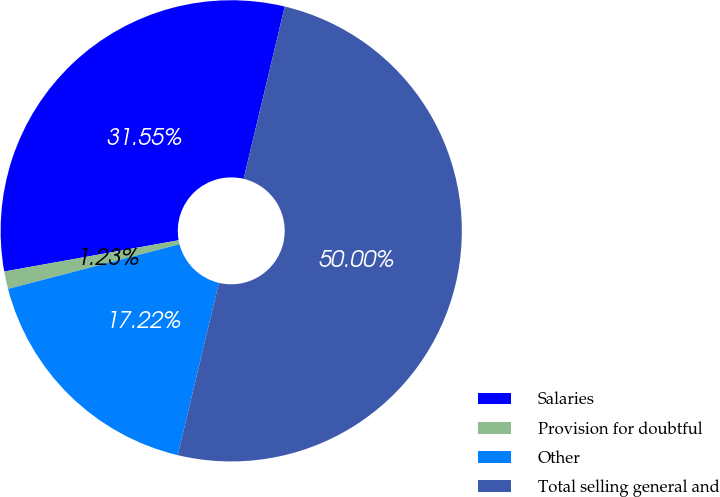Convert chart to OTSL. <chart><loc_0><loc_0><loc_500><loc_500><pie_chart><fcel>Salaries<fcel>Provision for doubtful<fcel>Other<fcel>Total selling general and<nl><fcel>31.55%<fcel>1.23%<fcel>17.22%<fcel>50.0%<nl></chart> 